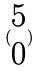Convert formula to latex. <formula><loc_0><loc_0><loc_500><loc_500>( \begin{matrix} 5 \\ 0 \end{matrix} )</formula> 